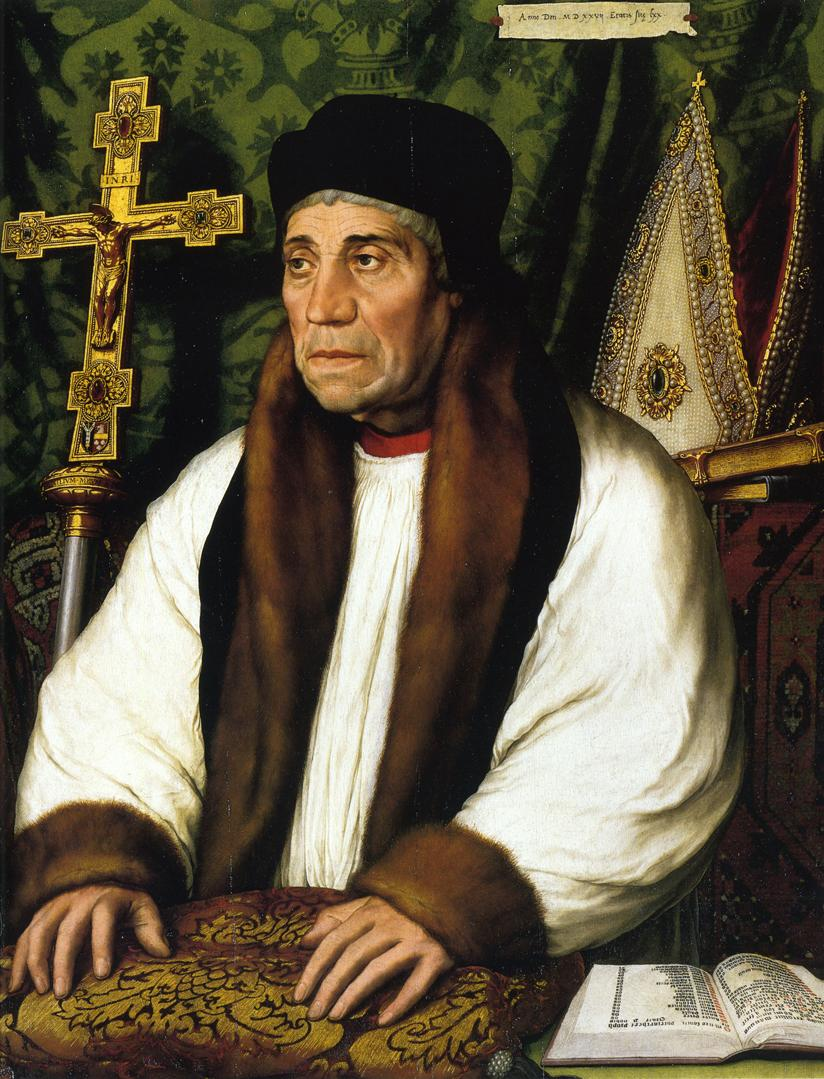Describe the potential historical context of this image. The image appears to be set in a historical context, likely from the Renaissance or a similar period. The detailed and opulent attire, the presence of religious symbols, and the setting suggest that the man might be a high-ranking church official or scholar. During this time, portraits were often commissioned to convey the importance and status of the subject, and the meticulous detail in the man's attire and the background reflects the artistic standards of that era. Imagine if the man in the portrait could talk. What do you think he would say about his life and position? If the man in the portrait could speak, he might say, 'I have devoted my life to the service of the church and the pursuit of knowledge. My journey has been one of contemplation, prayer, and the meticulous study of sacred texts. This portrait captures my dedication and the respect I have earned in my lifelong vocation. The cross represents my unwavering faith, and the fur stole and rich surroundings reflect the esteem in which I am held by my peers.' What kind of stories could the objects in this image tell us? The objects in the image each tell a unique story. The ornate gold cross speaks of devotion and the central role of faith in the man's life. The book on the desk likely contains sacred texts, capturing countless hours of study and reflection. The luxurious fur stole and detailed tapestry hint at the man's status and the value placed on these symbols of office during his era. Together, these objects narrate a life of scholarly pursuit interwoven with deep religious devotion, set against a backdrop of wealth and ecclesiastical authority. 